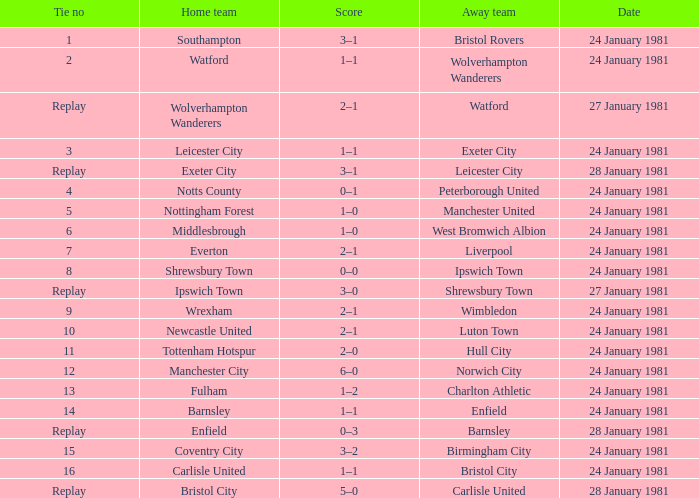What is the score when the deadlock is 8? 0–0. 